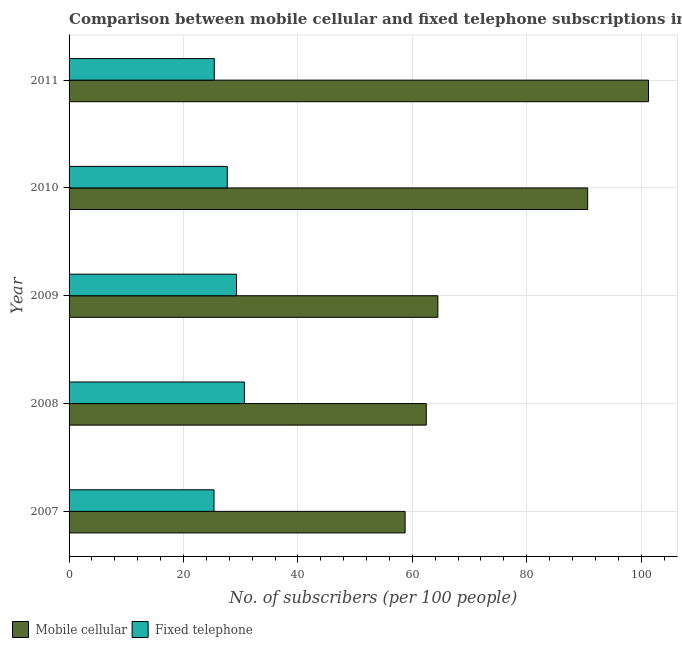How many different coloured bars are there?
Keep it short and to the point. 2. How many groups of bars are there?
Make the answer very short. 5. Are the number of bars per tick equal to the number of legend labels?
Your answer should be compact. Yes. Are the number of bars on each tick of the Y-axis equal?
Offer a terse response. Yes. How many bars are there on the 1st tick from the bottom?
Your response must be concise. 2. What is the label of the 1st group of bars from the top?
Make the answer very short. 2011. In how many cases, is the number of bars for a given year not equal to the number of legend labels?
Offer a terse response. 0. What is the number of fixed telephone subscribers in 2009?
Offer a very short reply. 29.27. Across all years, what is the maximum number of fixed telephone subscribers?
Your answer should be very brief. 30.65. Across all years, what is the minimum number of mobile cellular subscribers?
Keep it short and to the point. 58.74. In which year was the number of mobile cellular subscribers minimum?
Your answer should be compact. 2007. What is the total number of fixed telephone subscribers in the graph?
Provide a succinct answer. 138.29. What is the difference between the number of mobile cellular subscribers in 2009 and that in 2011?
Offer a terse response. -36.82. What is the difference between the number of mobile cellular subscribers in 2009 and the number of fixed telephone subscribers in 2011?
Your answer should be very brief. 39.08. What is the average number of fixed telephone subscribers per year?
Provide a short and direct response. 27.66. In the year 2011, what is the difference between the number of fixed telephone subscribers and number of mobile cellular subscribers?
Your answer should be compact. -75.9. In how many years, is the number of fixed telephone subscribers greater than 4 ?
Provide a short and direct response. 5. What is the ratio of the number of fixed telephone subscribers in 2007 to that in 2009?
Provide a succinct answer. 0.86. What is the difference between the highest and the second highest number of fixed telephone subscribers?
Make the answer very short. 1.37. What is the difference between the highest and the lowest number of mobile cellular subscribers?
Provide a short and direct response. 42.55. What does the 1st bar from the top in 2011 represents?
Give a very brief answer. Fixed telephone. What does the 2nd bar from the bottom in 2007 represents?
Your response must be concise. Fixed telephone. How many years are there in the graph?
Provide a succinct answer. 5. What is the difference between two consecutive major ticks on the X-axis?
Make the answer very short. 20. Where does the legend appear in the graph?
Provide a succinct answer. Bottom left. How many legend labels are there?
Offer a terse response. 2. How are the legend labels stacked?
Provide a succinct answer. Horizontal. What is the title of the graph?
Your answer should be very brief. Comparison between mobile cellular and fixed telephone subscriptions in Georgia. What is the label or title of the X-axis?
Provide a short and direct response. No. of subscribers (per 100 people). What is the No. of subscribers (per 100 people) of Mobile cellular in 2007?
Give a very brief answer. 58.74. What is the No. of subscribers (per 100 people) in Fixed telephone in 2007?
Provide a succinct answer. 25.34. What is the No. of subscribers (per 100 people) in Mobile cellular in 2008?
Your answer should be very brief. 62.44. What is the No. of subscribers (per 100 people) of Fixed telephone in 2008?
Keep it short and to the point. 30.65. What is the No. of subscribers (per 100 people) in Mobile cellular in 2009?
Provide a short and direct response. 64.46. What is the No. of subscribers (per 100 people) in Fixed telephone in 2009?
Ensure brevity in your answer.  29.27. What is the No. of subscribers (per 100 people) in Mobile cellular in 2010?
Your answer should be compact. 90.65. What is the No. of subscribers (per 100 people) of Fixed telephone in 2010?
Offer a very short reply. 27.65. What is the No. of subscribers (per 100 people) of Mobile cellular in 2011?
Make the answer very short. 101.28. What is the No. of subscribers (per 100 people) in Fixed telephone in 2011?
Keep it short and to the point. 25.39. Across all years, what is the maximum No. of subscribers (per 100 people) in Mobile cellular?
Provide a succinct answer. 101.28. Across all years, what is the maximum No. of subscribers (per 100 people) in Fixed telephone?
Provide a short and direct response. 30.65. Across all years, what is the minimum No. of subscribers (per 100 people) of Mobile cellular?
Provide a succinct answer. 58.74. Across all years, what is the minimum No. of subscribers (per 100 people) in Fixed telephone?
Offer a terse response. 25.34. What is the total No. of subscribers (per 100 people) in Mobile cellular in the graph?
Offer a very short reply. 377.57. What is the total No. of subscribers (per 100 people) in Fixed telephone in the graph?
Keep it short and to the point. 138.29. What is the difference between the No. of subscribers (per 100 people) in Mobile cellular in 2007 and that in 2008?
Offer a very short reply. -3.7. What is the difference between the No. of subscribers (per 100 people) in Fixed telephone in 2007 and that in 2008?
Ensure brevity in your answer.  -5.31. What is the difference between the No. of subscribers (per 100 people) in Mobile cellular in 2007 and that in 2009?
Make the answer very short. -5.72. What is the difference between the No. of subscribers (per 100 people) in Fixed telephone in 2007 and that in 2009?
Your answer should be very brief. -3.94. What is the difference between the No. of subscribers (per 100 people) of Mobile cellular in 2007 and that in 2010?
Your answer should be very brief. -31.91. What is the difference between the No. of subscribers (per 100 people) in Fixed telephone in 2007 and that in 2010?
Make the answer very short. -2.32. What is the difference between the No. of subscribers (per 100 people) in Mobile cellular in 2007 and that in 2011?
Your answer should be very brief. -42.55. What is the difference between the No. of subscribers (per 100 people) in Fixed telephone in 2007 and that in 2011?
Keep it short and to the point. -0.05. What is the difference between the No. of subscribers (per 100 people) of Mobile cellular in 2008 and that in 2009?
Ensure brevity in your answer.  -2.02. What is the difference between the No. of subscribers (per 100 people) in Fixed telephone in 2008 and that in 2009?
Your answer should be very brief. 1.37. What is the difference between the No. of subscribers (per 100 people) in Mobile cellular in 2008 and that in 2010?
Provide a succinct answer. -28.21. What is the difference between the No. of subscribers (per 100 people) in Fixed telephone in 2008 and that in 2010?
Offer a very short reply. 2.99. What is the difference between the No. of subscribers (per 100 people) of Mobile cellular in 2008 and that in 2011?
Make the answer very short. -38.84. What is the difference between the No. of subscribers (per 100 people) in Fixed telephone in 2008 and that in 2011?
Your answer should be compact. 5.26. What is the difference between the No. of subscribers (per 100 people) in Mobile cellular in 2009 and that in 2010?
Your answer should be very brief. -26.19. What is the difference between the No. of subscribers (per 100 people) of Fixed telephone in 2009 and that in 2010?
Your answer should be very brief. 1.62. What is the difference between the No. of subscribers (per 100 people) in Mobile cellular in 2009 and that in 2011?
Make the answer very short. -36.82. What is the difference between the No. of subscribers (per 100 people) in Fixed telephone in 2009 and that in 2011?
Offer a very short reply. 3.89. What is the difference between the No. of subscribers (per 100 people) of Mobile cellular in 2010 and that in 2011?
Your response must be concise. -10.63. What is the difference between the No. of subscribers (per 100 people) of Fixed telephone in 2010 and that in 2011?
Give a very brief answer. 2.27. What is the difference between the No. of subscribers (per 100 people) in Mobile cellular in 2007 and the No. of subscribers (per 100 people) in Fixed telephone in 2008?
Give a very brief answer. 28.09. What is the difference between the No. of subscribers (per 100 people) of Mobile cellular in 2007 and the No. of subscribers (per 100 people) of Fixed telephone in 2009?
Ensure brevity in your answer.  29.46. What is the difference between the No. of subscribers (per 100 people) of Mobile cellular in 2007 and the No. of subscribers (per 100 people) of Fixed telephone in 2010?
Your answer should be compact. 31.09. What is the difference between the No. of subscribers (per 100 people) of Mobile cellular in 2007 and the No. of subscribers (per 100 people) of Fixed telephone in 2011?
Your response must be concise. 33.35. What is the difference between the No. of subscribers (per 100 people) of Mobile cellular in 2008 and the No. of subscribers (per 100 people) of Fixed telephone in 2009?
Ensure brevity in your answer.  33.16. What is the difference between the No. of subscribers (per 100 people) of Mobile cellular in 2008 and the No. of subscribers (per 100 people) of Fixed telephone in 2010?
Make the answer very short. 34.79. What is the difference between the No. of subscribers (per 100 people) of Mobile cellular in 2008 and the No. of subscribers (per 100 people) of Fixed telephone in 2011?
Keep it short and to the point. 37.05. What is the difference between the No. of subscribers (per 100 people) of Mobile cellular in 2009 and the No. of subscribers (per 100 people) of Fixed telephone in 2010?
Your response must be concise. 36.81. What is the difference between the No. of subscribers (per 100 people) in Mobile cellular in 2009 and the No. of subscribers (per 100 people) in Fixed telephone in 2011?
Your answer should be very brief. 39.08. What is the difference between the No. of subscribers (per 100 people) of Mobile cellular in 2010 and the No. of subscribers (per 100 people) of Fixed telephone in 2011?
Make the answer very short. 65.26. What is the average No. of subscribers (per 100 people) of Mobile cellular per year?
Provide a short and direct response. 75.51. What is the average No. of subscribers (per 100 people) of Fixed telephone per year?
Keep it short and to the point. 27.66. In the year 2007, what is the difference between the No. of subscribers (per 100 people) of Mobile cellular and No. of subscribers (per 100 people) of Fixed telephone?
Give a very brief answer. 33.4. In the year 2008, what is the difference between the No. of subscribers (per 100 people) of Mobile cellular and No. of subscribers (per 100 people) of Fixed telephone?
Offer a terse response. 31.79. In the year 2009, what is the difference between the No. of subscribers (per 100 people) in Mobile cellular and No. of subscribers (per 100 people) in Fixed telephone?
Your answer should be very brief. 35.19. In the year 2010, what is the difference between the No. of subscribers (per 100 people) of Mobile cellular and No. of subscribers (per 100 people) of Fixed telephone?
Your answer should be compact. 63. In the year 2011, what is the difference between the No. of subscribers (per 100 people) in Mobile cellular and No. of subscribers (per 100 people) in Fixed telephone?
Your answer should be very brief. 75.9. What is the ratio of the No. of subscribers (per 100 people) in Mobile cellular in 2007 to that in 2008?
Your response must be concise. 0.94. What is the ratio of the No. of subscribers (per 100 people) of Fixed telephone in 2007 to that in 2008?
Provide a short and direct response. 0.83. What is the ratio of the No. of subscribers (per 100 people) of Mobile cellular in 2007 to that in 2009?
Ensure brevity in your answer.  0.91. What is the ratio of the No. of subscribers (per 100 people) of Fixed telephone in 2007 to that in 2009?
Offer a terse response. 0.87. What is the ratio of the No. of subscribers (per 100 people) of Mobile cellular in 2007 to that in 2010?
Offer a terse response. 0.65. What is the ratio of the No. of subscribers (per 100 people) in Fixed telephone in 2007 to that in 2010?
Make the answer very short. 0.92. What is the ratio of the No. of subscribers (per 100 people) in Mobile cellular in 2007 to that in 2011?
Give a very brief answer. 0.58. What is the ratio of the No. of subscribers (per 100 people) in Mobile cellular in 2008 to that in 2009?
Keep it short and to the point. 0.97. What is the ratio of the No. of subscribers (per 100 people) of Fixed telephone in 2008 to that in 2009?
Provide a short and direct response. 1.05. What is the ratio of the No. of subscribers (per 100 people) of Mobile cellular in 2008 to that in 2010?
Keep it short and to the point. 0.69. What is the ratio of the No. of subscribers (per 100 people) in Fixed telephone in 2008 to that in 2010?
Provide a short and direct response. 1.11. What is the ratio of the No. of subscribers (per 100 people) in Mobile cellular in 2008 to that in 2011?
Provide a short and direct response. 0.62. What is the ratio of the No. of subscribers (per 100 people) of Fixed telephone in 2008 to that in 2011?
Keep it short and to the point. 1.21. What is the ratio of the No. of subscribers (per 100 people) in Mobile cellular in 2009 to that in 2010?
Keep it short and to the point. 0.71. What is the ratio of the No. of subscribers (per 100 people) of Fixed telephone in 2009 to that in 2010?
Offer a very short reply. 1.06. What is the ratio of the No. of subscribers (per 100 people) in Mobile cellular in 2009 to that in 2011?
Make the answer very short. 0.64. What is the ratio of the No. of subscribers (per 100 people) of Fixed telephone in 2009 to that in 2011?
Offer a terse response. 1.15. What is the ratio of the No. of subscribers (per 100 people) of Mobile cellular in 2010 to that in 2011?
Your response must be concise. 0.9. What is the ratio of the No. of subscribers (per 100 people) in Fixed telephone in 2010 to that in 2011?
Offer a very short reply. 1.09. What is the difference between the highest and the second highest No. of subscribers (per 100 people) in Mobile cellular?
Provide a short and direct response. 10.63. What is the difference between the highest and the second highest No. of subscribers (per 100 people) of Fixed telephone?
Give a very brief answer. 1.37. What is the difference between the highest and the lowest No. of subscribers (per 100 people) of Mobile cellular?
Keep it short and to the point. 42.55. What is the difference between the highest and the lowest No. of subscribers (per 100 people) in Fixed telephone?
Your answer should be very brief. 5.31. 